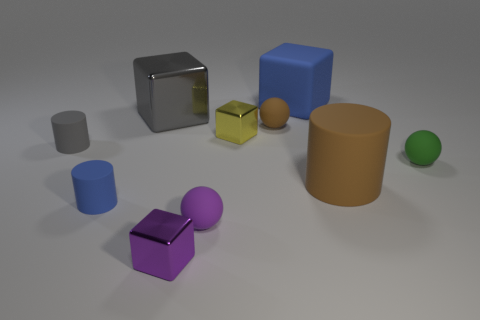Subtract 2 cubes. How many cubes are left? 2 Subtract all green cubes. Subtract all gray balls. How many cubes are left? 4 Subtract all cylinders. How many objects are left? 7 Add 7 brown cylinders. How many brown cylinders are left? 8 Add 4 small blue matte spheres. How many small blue matte spheres exist? 4 Subtract 1 blue cubes. How many objects are left? 9 Subtract all cylinders. Subtract all yellow metallic blocks. How many objects are left? 6 